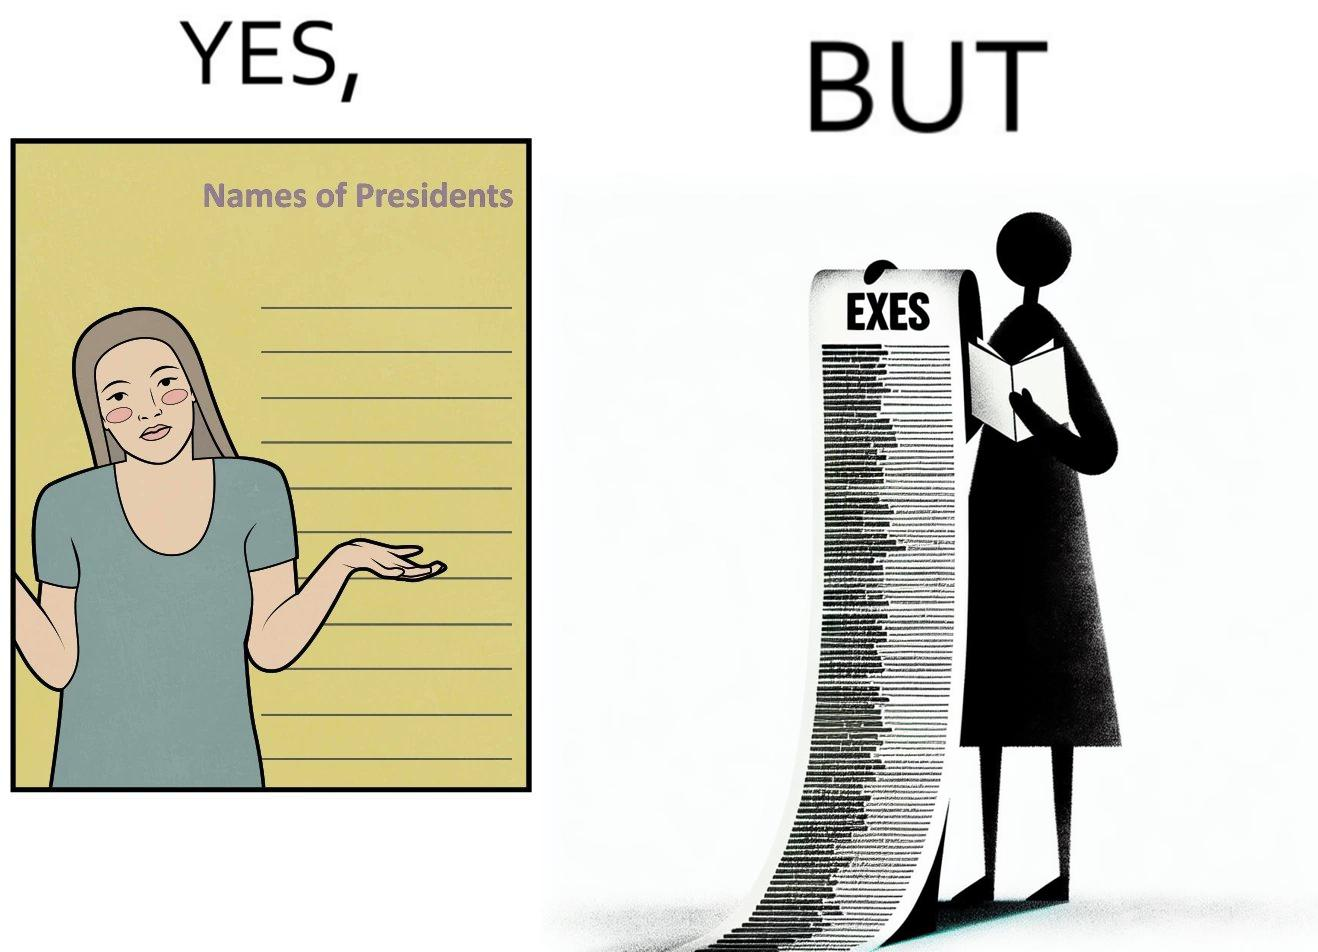What is shown in this image? The images are funny since it shows how people tend to forget the important details like names of presidents but remember the useless ones, like forgetting names of presidents but remembering the names of their exes in this example 